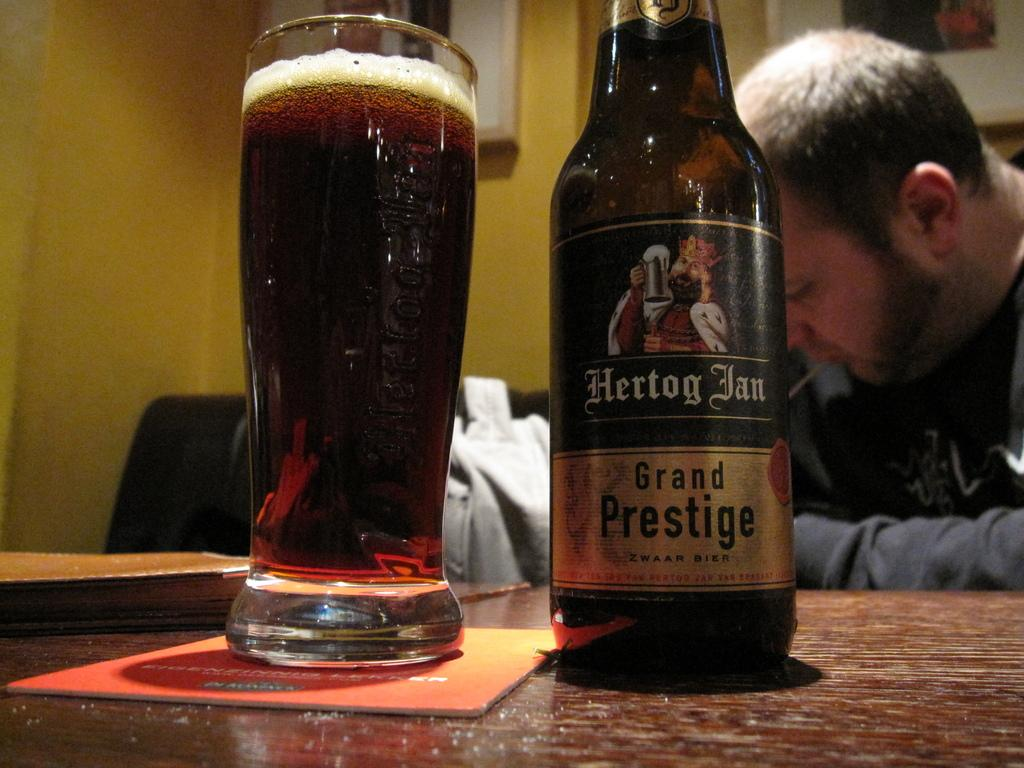<image>
Summarize the visual content of the image. A bottle of Herlog grand prestige ale sits on a table 